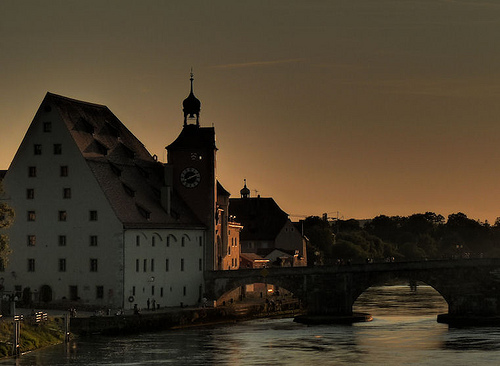<image>What city is this? I don't know what city this is. It could be Boston, Paris, London, Danube, or Florence. What city is this? I don't know what city this is. It can be either Boston, Paris, London, Danube, or Florence. 